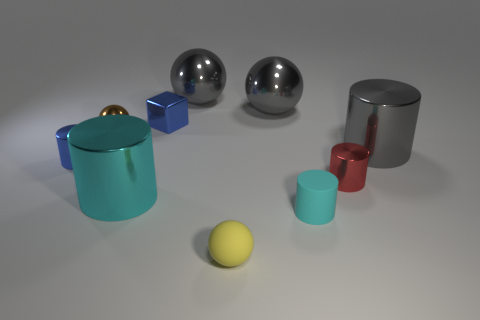Are these objects meant to indicate a particular scale or do they represent multiple sizes? In the image, the objects represent multiple sizes, which can be inferred from their relative proportions to each other. The objects vary from smaller items such as the blue cube and the yellow ball to larger items like the silver spheres and the cylindrical shapes. Can you tell which of the objects is the smallest and which is the largest? The smallest object appears to be the blue cube, while the largest object is the brown cylindrical shape. Their sizes can be compared based on their proximity and comparison with surrounding items. 